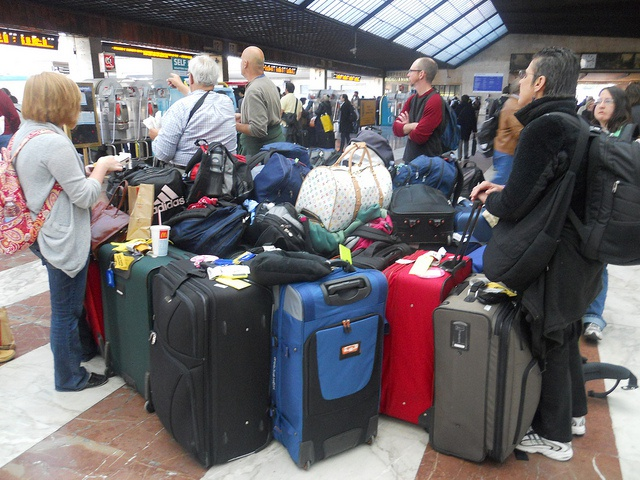Describe the objects in this image and their specific colors. I can see people in black, gray, and darkgray tones, suitcase in black, gray, and white tones, suitcase in black, blue, darkblue, and gray tones, people in black, lightgray, darkgray, navy, and darkblue tones, and suitcase in black, gray, and darkgray tones in this image. 